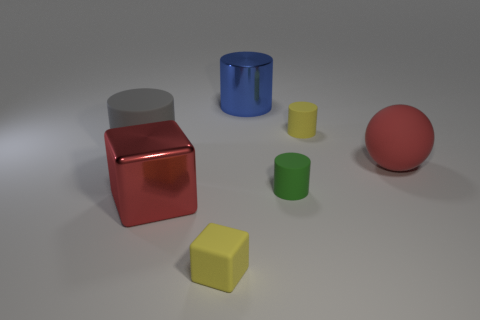Subtract all small green cylinders. How many cylinders are left? 3 Subtract all blue cylinders. How many cylinders are left? 3 Subtract all balls. How many objects are left? 6 Subtract 3 cylinders. How many cylinders are left? 1 Subtract all yellow objects. Subtract all big red metal blocks. How many objects are left? 4 Add 4 large red metallic blocks. How many large red metallic blocks are left? 5 Add 4 shiny cubes. How many shiny cubes exist? 5 Add 3 big red spheres. How many objects exist? 10 Subtract 0 purple blocks. How many objects are left? 7 Subtract all gray spheres. Subtract all purple cylinders. How many spheres are left? 1 